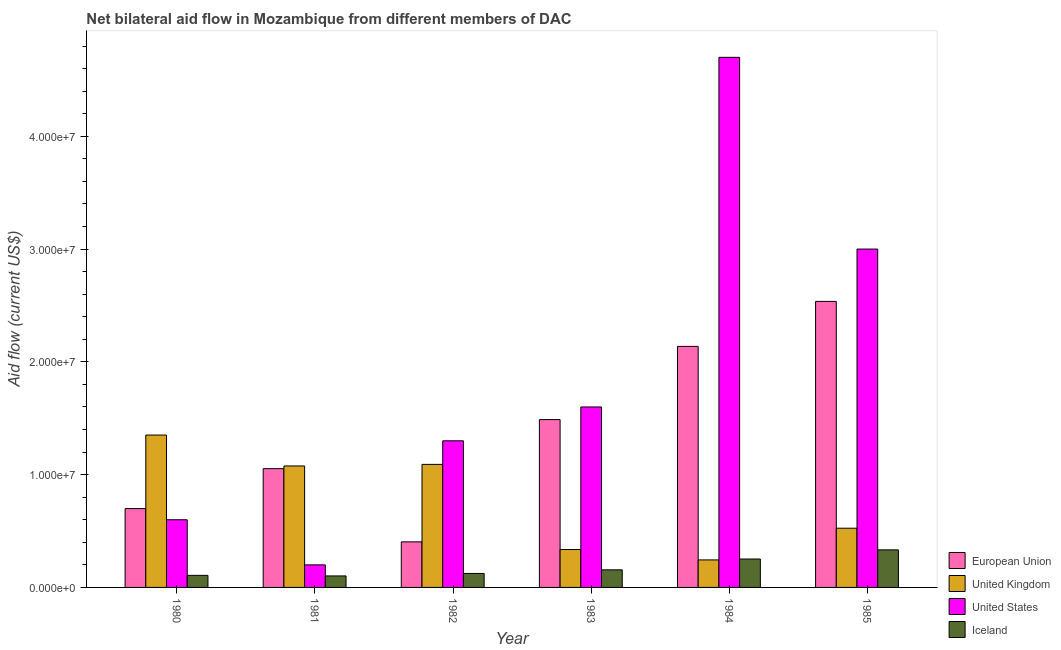How many groups of bars are there?
Make the answer very short. 6. Are the number of bars per tick equal to the number of legend labels?
Your answer should be compact. Yes. Are the number of bars on each tick of the X-axis equal?
Provide a short and direct response. Yes. How many bars are there on the 3rd tick from the right?
Keep it short and to the point. 4. What is the label of the 1st group of bars from the left?
Provide a short and direct response. 1980. What is the amount of aid given by eu in 1980?
Provide a short and direct response. 6.99e+06. Across all years, what is the maximum amount of aid given by iceland?
Your answer should be very brief. 3.33e+06. Across all years, what is the minimum amount of aid given by iceland?
Make the answer very short. 1.02e+06. In which year was the amount of aid given by iceland minimum?
Your answer should be compact. 1981. What is the total amount of aid given by us in the graph?
Keep it short and to the point. 1.14e+08. What is the difference between the amount of aid given by uk in 1981 and that in 1983?
Offer a very short reply. 7.41e+06. What is the difference between the amount of aid given by iceland in 1983 and the amount of aid given by uk in 1984?
Ensure brevity in your answer.  -9.60e+05. What is the average amount of aid given by uk per year?
Give a very brief answer. 7.71e+06. In the year 1981, what is the difference between the amount of aid given by iceland and amount of aid given by us?
Provide a short and direct response. 0. What is the ratio of the amount of aid given by eu in 1980 to that in 1982?
Make the answer very short. 1.73. Is the difference between the amount of aid given by us in 1981 and 1982 greater than the difference between the amount of aid given by iceland in 1981 and 1982?
Ensure brevity in your answer.  No. What is the difference between the highest and the second highest amount of aid given by eu?
Provide a short and direct response. 3.99e+06. What is the difference between the highest and the lowest amount of aid given by iceland?
Your response must be concise. 2.31e+06. In how many years, is the amount of aid given by iceland greater than the average amount of aid given by iceland taken over all years?
Make the answer very short. 2. Is it the case that in every year, the sum of the amount of aid given by eu and amount of aid given by iceland is greater than the sum of amount of aid given by uk and amount of aid given by us?
Offer a terse response. No. What does the 1st bar from the right in 1983 represents?
Ensure brevity in your answer.  Iceland. Is it the case that in every year, the sum of the amount of aid given by eu and amount of aid given by uk is greater than the amount of aid given by us?
Your answer should be very brief. No. Are all the bars in the graph horizontal?
Offer a terse response. No. How many years are there in the graph?
Your answer should be compact. 6. What is the difference between two consecutive major ticks on the Y-axis?
Ensure brevity in your answer.  1.00e+07. What is the title of the graph?
Your answer should be very brief. Net bilateral aid flow in Mozambique from different members of DAC. Does "Secondary general education" appear as one of the legend labels in the graph?
Your response must be concise. No. What is the label or title of the X-axis?
Offer a very short reply. Year. What is the Aid flow (current US$) in European Union in 1980?
Offer a terse response. 6.99e+06. What is the Aid flow (current US$) in United Kingdom in 1980?
Ensure brevity in your answer.  1.35e+07. What is the Aid flow (current US$) of United States in 1980?
Keep it short and to the point. 6.00e+06. What is the Aid flow (current US$) of Iceland in 1980?
Provide a short and direct response. 1.07e+06. What is the Aid flow (current US$) in European Union in 1981?
Provide a succinct answer. 1.05e+07. What is the Aid flow (current US$) of United Kingdom in 1981?
Provide a succinct answer. 1.08e+07. What is the Aid flow (current US$) in Iceland in 1981?
Your answer should be very brief. 1.02e+06. What is the Aid flow (current US$) of European Union in 1982?
Offer a terse response. 4.04e+06. What is the Aid flow (current US$) of United Kingdom in 1982?
Your answer should be very brief. 1.09e+07. What is the Aid flow (current US$) in United States in 1982?
Provide a short and direct response. 1.30e+07. What is the Aid flow (current US$) of Iceland in 1982?
Keep it short and to the point. 1.24e+06. What is the Aid flow (current US$) in European Union in 1983?
Your answer should be very brief. 1.49e+07. What is the Aid flow (current US$) in United Kingdom in 1983?
Offer a terse response. 3.36e+06. What is the Aid flow (current US$) of United States in 1983?
Your answer should be compact. 1.60e+07. What is the Aid flow (current US$) in Iceland in 1983?
Your answer should be very brief. 1.56e+06. What is the Aid flow (current US$) of European Union in 1984?
Your response must be concise. 2.14e+07. What is the Aid flow (current US$) of United Kingdom in 1984?
Offer a terse response. 2.44e+06. What is the Aid flow (current US$) of United States in 1984?
Provide a short and direct response. 4.70e+07. What is the Aid flow (current US$) of Iceland in 1984?
Provide a short and direct response. 2.52e+06. What is the Aid flow (current US$) in European Union in 1985?
Your answer should be very brief. 2.54e+07. What is the Aid flow (current US$) in United Kingdom in 1985?
Ensure brevity in your answer.  5.25e+06. What is the Aid flow (current US$) in United States in 1985?
Offer a very short reply. 3.00e+07. What is the Aid flow (current US$) in Iceland in 1985?
Your answer should be compact. 3.33e+06. Across all years, what is the maximum Aid flow (current US$) in European Union?
Keep it short and to the point. 2.54e+07. Across all years, what is the maximum Aid flow (current US$) of United Kingdom?
Provide a short and direct response. 1.35e+07. Across all years, what is the maximum Aid flow (current US$) of United States?
Give a very brief answer. 4.70e+07. Across all years, what is the maximum Aid flow (current US$) in Iceland?
Offer a very short reply. 3.33e+06. Across all years, what is the minimum Aid flow (current US$) of European Union?
Your response must be concise. 4.04e+06. Across all years, what is the minimum Aid flow (current US$) in United Kingdom?
Give a very brief answer. 2.44e+06. Across all years, what is the minimum Aid flow (current US$) of Iceland?
Keep it short and to the point. 1.02e+06. What is the total Aid flow (current US$) in European Union in the graph?
Give a very brief answer. 8.32e+07. What is the total Aid flow (current US$) of United Kingdom in the graph?
Provide a succinct answer. 4.62e+07. What is the total Aid flow (current US$) in United States in the graph?
Keep it short and to the point. 1.14e+08. What is the total Aid flow (current US$) in Iceland in the graph?
Provide a short and direct response. 1.07e+07. What is the difference between the Aid flow (current US$) in European Union in 1980 and that in 1981?
Provide a succinct answer. -3.54e+06. What is the difference between the Aid flow (current US$) in United Kingdom in 1980 and that in 1981?
Your answer should be very brief. 2.74e+06. What is the difference between the Aid flow (current US$) of Iceland in 1980 and that in 1981?
Make the answer very short. 5.00e+04. What is the difference between the Aid flow (current US$) of European Union in 1980 and that in 1982?
Provide a succinct answer. 2.95e+06. What is the difference between the Aid flow (current US$) in United Kingdom in 1980 and that in 1982?
Your response must be concise. 2.60e+06. What is the difference between the Aid flow (current US$) in United States in 1980 and that in 1982?
Keep it short and to the point. -7.00e+06. What is the difference between the Aid flow (current US$) of European Union in 1980 and that in 1983?
Provide a short and direct response. -7.89e+06. What is the difference between the Aid flow (current US$) of United Kingdom in 1980 and that in 1983?
Provide a succinct answer. 1.02e+07. What is the difference between the Aid flow (current US$) of United States in 1980 and that in 1983?
Your answer should be compact. -1.00e+07. What is the difference between the Aid flow (current US$) of Iceland in 1980 and that in 1983?
Provide a succinct answer. -4.90e+05. What is the difference between the Aid flow (current US$) in European Union in 1980 and that in 1984?
Provide a short and direct response. -1.44e+07. What is the difference between the Aid flow (current US$) of United Kingdom in 1980 and that in 1984?
Your answer should be compact. 1.11e+07. What is the difference between the Aid flow (current US$) of United States in 1980 and that in 1984?
Offer a terse response. -4.10e+07. What is the difference between the Aid flow (current US$) in Iceland in 1980 and that in 1984?
Ensure brevity in your answer.  -1.45e+06. What is the difference between the Aid flow (current US$) of European Union in 1980 and that in 1985?
Your answer should be compact. -1.84e+07. What is the difference between the Aid flow (current US$) of United Kingdom in 1980 and that in 1985?
Give a very brief answer. 8.26e+06. What is the difference between the Aid flow (current US$) of United States in 1980 and that in 1985?
Make the answer very short. -2.40e+07. What is the difference between the Aid flow (current US$) of Iceland in 1980 and that in 1985?
Offer a very short reply. -2.26e+06. What is the difference between the Aid flow (current US$) in European Union in 1981 and that in 1982?
Keep it short and to the point. 6.49e+06. What is the difference between the Aid flow (current US$) in United States in 1981 and that in 1982?
Offer a very short reply. -1.10e+07. What is the difference between the Aid flow (current US$) of Iceland in 1981 and that in 1982?
Keep it short and to the point. -2.20e+05. What is the difference between the Aid flow (current US$) in European Union in 1981 and that in 1983?
Offer a terse response. -4.35e+06. What is the difference between the Aid flow (current US$) in United Kingdom in 1981 and that in 1983?
Give a very brief answer. 7.41e+06. What is the difference between the Aid flow (current US$) of United States in 1981 and that in 1983?
Your answer should be compact. -1.40e+07. What is the difference between the Aid flow (current US$) in Iceland in 1981 and that in 1983?
Provide a succinct answer. -5.40e+05. What is the difference between the Aid flow (current US$) of European Union in 1981 and that in 1984?
Make the answer very short. -1.08e+07. What is the difference between the Aid flow (current US$) of United Kingdom in 1981 and that in 1984?
Your answer should be very brief. 8.33e+06. What is the difference between the Aid flow (current US$) of United States in 1981 and that in 1984?
Make the answer very short. -4.50e+07. What is the difference between the Aid flow (current US$) in Iceland in 1981 and that in 1984?
Ensure brevity in your answer.  -1.50e+06. What is the difference between the Aid flow (current US$) of European Union in 1981 and that in 1985?
Keep it short and to the point. -1.48e+07. What is the difference between the Aid flow (current US$) in United Kingdom in 1981 and that in 1985?
Keep it short and to the point. 5.52e+06. What is the difference between the Aid flow (current US$) of United States in 1981 and that in 1985?
Your answer should be compact. -2.80e+07. What is the difference between the Aid flow (current US$) of Iceland in 1981 and that in 1985?
Ensure brevity in your answer.  -2.31e+06. What is the difference between the Aid flow (current US$) of European Union in 1982 and that in 1983?
Offer a very short reply. -1.08e+07. What is the difference between the Aid flow (current US$) of United Kingdom in 1982 and that in 1983?
Make the answer very short. 7.55e+06. What is the difference between the Aid flow (current US$) of United States in 1982 and that in 1983?
Offer a terse response. -3.00e+06. What is the difference between the Aid flow (current US$) in Iceland in 1982 and that in 1983?
Offer a very short reply. -3.20e+05. What is the difference between the Aid flow (current US$) of European Union in 1982 and that in 1984?
Make the answer very short. -1.73e+07. What is the difference between the Aid flow (current US$) of United Kingdom in 1982 and that in 1984?
Your answer should be very brief. 8.47e+06. What is the difference between the Aid flow (current US$) in United States in 1982 and that in 1984?
Keep it short and to the point. -3.40e+07. What is the difference between the Aid flow (current US$) in Iceland in 1982 and that in 1984?
Provide a short and direct response. -1.28e+06. What is the difference between the Aid flow (current US$) of European Union in 1982 and that in 1985?
Keep it short and to the point. -2.13e+07. What is the difference between the Aid flow (current US$) of United Kingdom in 1982 and that in 1985?
Provide a short and direct response. 5.66e+06. What is the difference between the Aid flow (current US$) of United States in 1982 and that in 1985?
Make the answer very short. -1.70e+07. What is the difference between the Aid flow (current US$) of Iceland in 1982 and that in 1985?
Keep it short and to the point. -2.09e+06. What is the difference between the Aid flow (current US$) of European Union in 1983 and that in 1984?
Offer a very short reply. -6.49e+06. What is the difference between the Aid flow (current US$) in United Kingdom in 1983 and that in 1984?
Offer a very short reply. 9.20e+05. What is the difference between the Aid flow (current US$) of United States in 1983 and that in 1984?
Offer a terse response. -3.10e+07. What is the difference between the Aid flow (current US$) of Iceland in 1983 and that in 1984?
Your response must be concise. -9.60e+05. What is the difference between the Aid flow (current US$) of European Union in 1983 and that in 1985?
Ensure brevity in your answer.  -1.05e+07. What is the difference between the Aid flow (current US$) of United Kingdom in 1983 and that in 1985?
Make the answer very short. -1.89e+06. What is the difference between the Aid flow (current US$) in United States in 1983 and that in 1985?
Keep it short and to the point. -1.40e+07. What is the difference between the Aid flow (current US$) in Iceland in 1983 and that in 1985?
Ensure brevity in your answer.  -1.77e+06. What is the difference between the Aid flow (current US$) in European Union in 1984 and that in 1985?
Your answer should be compact. -3.99e+06. What is the difference between the Aid flow (current US$) of United Kingdom in 1984 and that in 1985?
Offer a very short reply. -2.81e+06. What is the difference between the Aid flow (current US$) in United States in 1984 and that in 1985?
Offer a terse response. 1.70e+07. What is the difference between the Aid flow (current US$) in Iceland in 1984 and that in 1985?
Provide a succinct answer. -8.10e+05. What is the difference between the Aid flow (current US$) in European Union in 1980 and the Aid flow (current US$) in United Kingdom in 1981?
Your answer should be very brief. -3.78e+06. What is the difference between the Aid flow (current US$) of European Union in 1980 and the Aid flow (current US$) of United States in 1981?
Your response must be concise. 4.99e+06. What is the difference between the Aid flow (current US$) in European Union in 1980 and the Aid flow (current US$) in Iceland in 1981?
Keep it short and to the point. 5.97e+06. What is the difference between the Aid flow (current US$) in United Kingdom in 1980 and the Aid flow (current US$) in United States in 1981?
Give a very brief answer. 1.15e+07. What is the difference between the Aid flow (current US$) in United Kingdom in 1980 and the Aid flow (current US$) in Iceland in 1981?
Ensure brevity in your answer.  1.25e+07. What is the difference between the Aid flow (current US$) of United States in 1980 and the Aid flow (current US$) of Iceland in 1981?
Keep it short and to the point. 4.98e+06. What is the difference between the Aid flow (current US$) in European Union in 1980 and the Aid flow (current US$) in United Kingdom in 1982?
Offer a terse response. -3.92e+06. What is the difference between the Aid flow (current US$) of European Union in 1980 and the Aid flow (current US$) of United States in 1982?
Offer a very short reply. -6.01e+06. What is the difference between the Aid flow (current US$) of European Union in 1980 and the Aid flow (current US$) of Iceland in 1982?
Your response must be concise. 5.75e+06. What is the difference between the Aid flow (current US$) of United Kingdom in 1980 and the Aid flow (current US$) of United States in 1982?
Provide a succinct answer. 5.10e+05. What is the difference between the Aid flow (current US$) in United Kingdom in 1980 and the Aid flow (current US$) in Iceland in 1982?
Offer a very short reply. 1.23e+07. What is the difference between the Aid flow (current US$) of United States in 1980 and the Aid flow (current US$) of Iceland in 1982?
Offer a terse response. 4.76e+06. What is the difference between the Aid flow (current US$) in European Union in 1980 and the Aid flow (current US$) in United Kingdom in 1983?
Make the answer very short. 3.63e+06. What is the difference between the Aid flow (current US$) of European Union in 1980 and the Aid flow (current US$) of United States in 1983?
Keep it short and to the point. -9.01e+06. What is the difference between the Aid flow (current US$) of European Union in 1980 and the Aid flow (current US$) of Iceland in 1983?
Ensure brevity in your answer.  5.43e+06. What is the difference between the Aid flow (current US$) in United Kingdom in 1980 and the Aid flow (current US$) in United States in 1983?
Your answer should be very brief. -2.49e+06. What is the difference between the Aid flow (current US$) in United Kingdom in 1980 and the Aid flow (current US$) in Iceland in 1983?
Offer a very short reply. 1.20e+07. What is the difference between the Aid flow (current US$) of United States in 1980 and the Aid flow (current US$) of Iceland in 1983?
Provide a short and direct response. 4.44e+06. What is the difference between the Aid flow (current US$) of European Union in 1980 and the Aid flow (current US$) of United Kingdom in 1984?
Provide a short and direct response. 4.55e+06. What is the difference between the Aid flow (current US$) in European Union in 1980 and the Aid flow (current US$) in United States in 1984?
Keep it short and to the point. -4.00e+07. What is the difference between the Aid flow (current US$) in European Union in 1980 and the Aid flow (current US$) in Iceland in 1984?
Your answer should be compact. 4.47e+06. What is the difference between the Aid flow (current US$) in United Kingdom in 1980 and the Aid flow (current US$) in United States in 1984?
Provide a short and direct response. -3.35e+07. What is the difference between the Aid flow (current US$) in United Kingdom in 1980 and the Aid flow (current US$) in Iceland in 1984?
Offer a terse response. 1.10e+07. What is the difference between the Aid flow (current US$) in United States in 1980 and the Aid flow (current US$) in Iceland in 1984?
Ensure brevity in your answer.  3.48e+06. What is the difference between the Aid flow (current US$) of European Union in 1980 and the Aid flow (current US$) of United Kingdom in 1985?
Make the answer very short. 1.74e+06. What is the difference between the Aid flow (current US$) of European Union in 1980 and the Aid flow (current US$) of United States in 1985?
Ensure brevity in your answer.  -2.30e+07. What is the difference between the Aid flow (current US$) in European Union in 1980 and the Aid flow (current US$) in Iceland in 1985?
Make the answer very short. 3.66e+06. What is the difference between the Aid flow (current US$) of United Kingdom in 1980 and the Aid flow (current US$) of United States in 1985?
Keep it short and to the point. -1.65e+07. What is the difference between the Aid flow (current US$) of United Kingdom in 1980 and the Aid flow (current US$) of Iceland in 1985?
Provide a succinct answer. 1.02e+07. What is the difference between the Aid flow (current US$) in United States in 1980 and the Aid flow (current US$) in Iceland in 1985?
Make the answer very short. 2.67e+06. What is the difference between the Aid flow (current US$) of European Union in 1981 and the Aid flow (current US$) of United Kingdom in 1982?
Keep it short and to the point. -3.80e+05. What is the difference between the Aid flow (current US$) in European Union in 1981 and the Aid flow (current US$) in United States in 1982?
Offer a very short reply. -2.47e+06. What is the difference between the Aid flow (current US$) in European Union in 1981 and the Aid flow (current US$) in Iceland in 1982?
Provide a succinct answer. 9.29e+06. What is the difference between the Aid flow (current US$) of United Kingdom in 1981 and the Aid flow (current US$) of United States in 1982?
Offer a terse response. -2.23e+06. What is the difference between the Aid flow (current US$) of United Kingdom in 1981 and the Aid flow (current US$) of Iceland in 1982?
Provide a short and direct response. 9.53e+06. What is the difference between the Aid flow (current US$) in United States in 1981 and the Aid flow (current US$) in Iceland in 1982?
Make the answer very short. 7.60e+05. What is the difference between the Aid flow (current US$) in European Union in 1981 and the Aid flow (current US$) in United Kingdom in 1983?
Ensure brevity in your answer.  7.17e+06. What is the difference between the Aid flow (current US$) in European Union in 1981 and the Aid flow (current US$) in United States in 1983?
Your response must be concise. -5.47e+06. What is the difference between the Aid flow (current US$) of European Union in 1981 and the Aid flow (current US$) of Iceland in 1983?
Provide a short and direct response. 8.97e+06. What is the difference between the Aid flow (current US$) in United Kingdom in 1981 and the Aid flow (current US$) in United States in 1983?
Make the answer very short. -5.23e+06. What is the difference between the Aid flow (current US$) of United Kingdom in 1981 and the Aid flow (current US$) of Iceland in 1983?
Provide a short and direct response. 9.21e+06. What is the difference between the Aid flow (current US$) of European Union in 1981 and the Aid flow (current US$) of United Kingdom in 1984?
Keep it short and to the point. 8.09e+06. What is the difference between the Aid flow (current US$) in European Union in 1981 and the Aid flow (current US$) in United States in 1984?
Keep it short and to the point. -3.65e+07. What is the difference between the Aid flow (current US$) of European Union in 1981 and the Aid flow (current US$) of Iceland in 1984?
Provide a short and direct response. 8.01e+06. What is the difference between the Aid flow (current US$) in United Kingdom in 1981 and the Aid flow (current US$) in United States in 1984?
Your answer should be compact. -3.62e+07. What is the difference between the Aid flow (current US$) in United Kingdom in 1981 and the Aid flow (current US$) in Iceland in 1984?
Provide a short and direct response. 8.25e+06. What is the difference between the Aid flow (current US$) of United States in 1981 and the Aid flow (current US$) of Iceland in 1984?
Provide a succinct answer. -5.20e+05. What is the difference between the Aid flow (current US$) in European Union in 1981 and the Aid flow (current US$) in United Kingdom in 1985?
Your answer should be very brief. 5.28e+06. What is the difference between the Aid flow (current US$) of European Union in 1981 and the Aid flow (current US$) of United States in 1985?
Make the answer very short. -1.95e+07. What is the difference between the Aid flow (current US$) of European Union in 1981 and the Aid flow (current US$) of Iceland in 1985?
Make the answer very short. 7.20e+06. What is the difference between the Aid flow (current US$) of United Kingdom in 1981 and the Aid flow (current US$) of United States in 1985?
Keep it short and to the point. -1.92e+07. What is the difference between the Aid flow (current US$) in United Kingdom in 1981 and the Aid flow (current US$) in Iceland in 1985?
Give a very brief answer. 7.44e+06. What is the difference between the Aid flow (current US$) in United States in 1981 and the Aid flow (current US$) in Iceland in 1985?
Make the answer very short. -1.33e+06. What is the difference between the Aid flow (current US$) in European Union in 1982 and the Aid flow (current US$) in United Kingdom in 1983?
Your answer should be compact. 6.80e+05. What is the difference between the Aid flow (current US$) in European Union in 1982 and the Aid flow (current US$) in United States in 1983?
Your answer should be compact. -1.20e+07. What is the difference between the Aid flow (current US$) of European Union in 1982 and the Aid flow (current US$) of Iceland in 1983?
Your response must be concise. 2.48e+06. What is the difference between the Aid flow (current US$) of United Kingdom in 1982 and the Aid flow (current US$) of United States in 1983?
Give a very brief answer. -5.09e+06. What is the difference between the Aid flow (current US$) of United Kingdom in 1982 and the Aid flow (current US$) of Iceland in 1983?
Your answer should be compact. 9.35e+06. What is the difference between the Aid flow (current US$) in United States in 1982 and the Aid flow (current US$) in Iceland in 1983?
Your answer should be very brief. 1.14e+07. What is the difference between the Aid flow (current US$) in European Union in 1982 and the Aid flow (current US$) in United Kingdom in 1984?
Give a very brief answer. 1.60e+06. What is the difference between the Aid flow (current US$) of European Union in 1982 and the Aid flow (current US$) of United States in 1984?
Keep it short and to the point. -4.30e+07. What is the difference between the Aid flow (current US$) of European Union in 1982 and the Aid flow (current US$) of Iceland in 1984?
Provide a short and direct response. 1.52e+06. What is the difference between the Aid flow (current US$) in United Kingdom in 1982 and the Aid flow (current US$) in United States in 1984?
Offer a terse response. -3.61e+07. What is the difference between the Aid flow (current US$) of United Kingdom in 1982 and the Aid flow (current US$) of Iceland in 1984?
Keep it short and to the point. 8.39e+06. What is the difference between the Aid flow (current US$) of United States in 1982 and the Aid flow (current US$) of Iceland in 1984?
Your answer should be very brief. 1.05e+07. What is the difference between the Aid flow (current US$) of European Union in 1982 and the Aid flow (current US$) of United Kingdom in 1985?
Your answer should be compact. -1.21e+06. What is the difference between the Aid flow (current US$) of European Union in 1982 and the Aid flow (current US$) of United States in 1985?
Provide a succinct answer. -2.60e+07. What is the difference between the Aid flow (current US$) in European Union in 1982 and the Aid flow (current US$) in Iceland in 1985?
Keep it short and to the point. 7.10e+05. What is the difference between the Aid flow (current US$) of United Kingdom in 1982 and the Aid flow (current US$) of United States in 1985?
Offer a terse response. -1.91e+07. What is the difference between the Aid flow (current US$) in United Kingdom in 1982 and the Aid flow (current US$) in Iceland in 1985?
Your response must be concise. 7.58e+06. What is the difference between the Aid flow (current US$) in United States in 1982 and the Aid flow (current US$) in Iceland in 1985?
Make the answer very short. 9.67e+06. What is the difference between the Aid flow (current US$) of European Union in 1983 and the Aid flow (current US$) of United Kingdom in 1984?
Make the answer very short. 1.24e+07. What is the difference between the Aid flow (current US$) in European Union in 1983 and the Aid flow (current US$) in United States in 1984?
Give a very brief answer. -3.21e+07. What is the difference between the Aid flow (current US$) in European Union in 1983 and the Aid flow (current US$) in Iceland in 1984?
Your response must be concise. 1.24e+07. What is the difference between the Aid flow (current US$) of United Kingdom in 1983 and the Aid flow (current US$) of United States in 1984?
Ensure brevity in your answer.  -4.36e+07. What is the difference between the Aid flow (current US$) of United Kingdom in 1983 and the Aid flow (current US$) of Iceland in 1984?
Ensure brevity in your answer.  8.40e+05. What is the difference between the Aid flow (current US$) of United States in 1983 and the Aid flow (current US$) of Iceland in 1984?
Offer a very short reply. 1.35e+07. What is the difference between the Aid flow (current US$) in European Union in 1983 and the Aid flow (current US$) in United Kingdom in 1985?
Make the answer very short. 9.63e+06. What is the difference between the Aid flow (current US$) in European Union in 1983 and the Aid flow (current US$) in United States in 1985?
Your response must be concise. -1.51e+07. What is the difference between the Aid flow (current US$) of European Union in 1983 and the Aid flow (current US$) of Iceland in 1985?
Your answer should be very brief. 1.16e+07. What is the difference between the Aid flow (current US$) in United Kingdom in 1983 and the Aid flow (current US$) in United States in 1985?
Make the answer very short. -2.66e+07. What is the difference between the Aid flow (current US$) in United Kingdom in 1983 and the Aid flow (current US$) in Iceland in 1985?
Offer a very short reply. 3.00e+04. What is the difference between the Aid flow (current US$) of United States in 1983 and the Aid flow (current US$) of Iceland in 1985?
Offer a terse response. 1.27e+07. What is the difference between the Aid flow (current US$) of European Union in 1984 and the Aid flow (current US$) of United Kingdom in 1985?
Your answer should be compact. 1.61e+07. What is the difference between the Aid flow (current US$) in European Union in 1984 and the Aid flow (current US$) in United States in 1985?
Provide a short and direct response. -8.63e+06. What is the difference between the Aid flow (current US$) in European Union in 1984 and the Aid flow (current US$) in Iceland in 1985?
Make the answer very short. 1.80e+07. What is the difference between the Aid flow (current US$) in United Kingdom in 1984 and the Aid flow (current US$) in United States in 1985?
Offer a very short reply. -2.76e+07. What is the difference between the Aid flow (current US$) of United Kingdom in 1984 and the Aid flow (current US$) of Iceland in 1985?
Your answer should be compact. -8.90e+05. What is the difference between the Aid flow (current US$) in United States in 1984 and the Aid flow (current US$) in Iceland in 1985?
Make the answer very short. 4.37e+07. What is the average Aid flow (current US$) of European Union per year?
Keep it short and to the point. 1.39e+07. What is the average Aid flow (current US$) in United Kingdom per year?
Make the answer very short. 7.71e+06. What is the average Aid flow (current US$) of United States per year?
Give a very brief answer. 1.90e+07. What is the average Aid flow (current US$) in Iceland per year?
Your answer should be compact. 1.79e+06. In the year 1980, what is the difference between the Aid flow (current US$) of European Union and Aid flow (current US$) of United Kingdom?
Your answer should be very brief. -6.52e+06. In the year 1980, what is the difference between the Aid flow (current US$) in European Union and Aid flow (current US$) in United States?
Your answer should be compact. 9.90e+05. In the year 1980, what is the difference between the Aid flow (current US$) of European Union and Aid flow (current US$) of Iceland?
Keep it short and to the point. 5.92e+06. In the year 1980, what is the difference between the Aid flow (current US$) of United Kingdom and Aid flow (current US$) of United States?
Offer a very short reply. 7.51e+06. In the year 1980, what is the difference between the Aid flow (current US$) of United Kingdom and Aid flow (current US$) of Iceland?
Ensure brevity in your answer.  1.24e+07. In the year 1980, what is the difference between the Aid flow (current US$) of United States and Aid flow (current US$) of Iceland?
Make the answer very short. 4.93e+06. In the year 1981, what is the difference between the Aid flow (current US$) of European Union and Aid flow (current US$) of United Kingdom?
Offer a very short reply. -2.40e+05. In the year 1981, what is the difference between the Aid flow (current US$) of European Union and Aid flow (current US$) of United States?
Keep it short and to the point. 8.53e+06. In the year 1981, what is the difference between the Aid flow (current US$) of European Union and Aid flow (current US$) of Iceland?
Your answer should be compact. 9.51e+06. In the year 1981, what is the difference between the Aid flow (current US$) of United Kingdom and Aid flow (current US$) of United States?
Make the answer very short. 8.77e+06. In the year 1981, what is the difference between the Aid flow (current US$) of United Kingdom and Aid flow (current US$) of Iceland?
Offer a terse response. 9.75e+06. In the year 1981, what is the difference between the Aid flow (current US$) in United States and Aid flow (current US$) in Iceland?
Make the answer very short. 9.80e+05. In the year 1982, what is the difference between the Aid flow (current US$) in European Union and Aid flow (current US$) in United Kingdom?
Provide a succinct answer. -6.87e+06. In the year 1982, what is the difference between the Aid flow (current US$) of European Union and Aid flow (current US$) of United States?
Provide a short and direct response. -8.96e+06. In the year 1982, what is the difference between the Aid flow (current US$) of European Union and Aid flow (current US$) of Iceland?
Keep it short and to the point. 2.80e+06. In the year 1982, what is the difference between the Aid flow (current US$) of United Kingdom and Aid flow (current US$) of United States?
Your answer should be very brief. -2.09e+06. In the year 1982, what is the difference between the Aid flow (current US$) of United Kingdom and Aid flow (current US$) of Iceland?
Give a very brief answer. 9.67e+06. In the year 1982, what is the difference between the Aid flow (current US$) of United States and Aid flow (current US$) of Iceland?
Your response must be concise. 1.18e+07. In the year 1983, what is the difference between the Aid flow (current US$) of European Union and Aid flow (current US$) of United Kingdom?
Offer a terse response. 1.15e+07. In the year 1983, what is the difference between the Aid flow (current US$) in European Union and Aid flow (current US$) in United States?
Keep it short and to the point. -1.12e+06. In the year 1983, what is the difference between the Aid flow (current US$) in European Union and Aid flow (current US$) in Iceland?
Keep it short and to the point. 1.33e+07. In the year 1983, what is the difference between the Aid flow (current US$) of United Kingdom and Aid flow (current US$) of United States?
Offer a terse response. -1.26e+07. In the year 1983, what is the difference between the Aid flow (current US$) of United Kingdom and Aid flow (current US$) of Iceland?
Your response must be concise. 1.80e+06. In the year 1983, what is the difference between the Aid flow (current US$) in United States and Aid flow (current US$) in Iceland?
Ensure brevity in your answer.  1.44e+07. In the year 1984, what is the difference between the Aid flow (current US$) of European Union and Aid flow (current US$) of United Kingdom?
Make the answer very short. 1.89e+07. In the year 1984, what is the difference between the Aid flow (current US$) in European Union and Aid flow (current US$) in United States?
Provide a short and direct response. -2.56e+07. In the year 1984, what is the difference between the Aid flow (current US$) in European Union and Aid flow (current US$) in Iceland?
Keep it short and to the point. 1.88e+07. In the year 1984, what is the difference between the Aid flow (current US$) in United Kingdom and Aid flow (current US$) in United States?
Your answer should be compact. -4.46e+07. In the year 1984, what is the difference between the Aid flow (current US$) of United States and Aid flow (current US$) of Iceland?
Make the answer very short. 4.45e+07. In the year 1985, what is the difference between the Aid flow (current US$) of European Union and Aid flow (current US$) of United Kingdom?
Your answer should be compact. 2.01e+07. In the year 1985, what is the difference between the Aid flow (current US$) of European Union and Aid flow (current US$) of United States?
Give a very brief answer. -4.64e+06. In the year 1985, what is the difference between the Aid flow (current US$) in European Union and Aid flow (current US$) in Iceland?
Offer a very short reply. 2.20e+07. In the year 1985, what is the difference between the Aid flow (current US$) of United Kingdom and Aid flow (current US$) of United States?
Provide a short and direct response. -2.48e+07. In the year 1985, what is the difference between the Aid flow (current US$) of United Kingdom and Aid flow (current US$) of Iceland?
Your answer should be compact. 1.92e+06. In the year 1985, what is the difference between the Aid flow (current US$) of United States and Aid flow (current US$) of Iceland?
Keep it short and to the point. 2.67e+07. What is the ratio of the Aid flow (current US$) in European Union in 1980 to that in 1981?
Provide a short and direct response. 0.66. What is the ratio of the Aid flow (current US$) of United Kingdom in 1980 to that in 1981?
Provide a succinct answer. 1.25. What is the ratio of the Aid flow (current US$) of Iceland in 1980 to that in 1981?
Keep it short and to the point. 1.05. What is the ratio of the Aid flow (current US$) in European Union in 1980 to that in 1982?
Make the answer very short. 1.73. What is the ratio of the Aid flow (current US$) of United Kingdom in 1980 to that in 1982?
Your answer should be very brief. 1.24. What is the ratio of the Aid flow (current US$) of United States in 1980 to that in 1982?
Your response must be concise. 0.46. What is the ratio of the Aid flow (current US$) in Iceland in 1980 to that in 1982?
Keep it short and to the point. 0.86. What is the ratio of the Aid flow (current US$) of European Union in 1980 to that in 1983?
Keep it short and to the point. 0.47. What is the ratio of the Aid flow (current US$) in United Kingdom in 1980 to that in 1983?
Give a very brief answer. 4.02. What is the ratio of the Aid flow (current US$) of United States in 1980 to that in 1983?
Provide a short and direct response. 0.38. What is the ratio of the Aid flow (current US$) in Iceland in 1980 to that in 1983?
Make the answer very short. 0.69. What is the ratio of the Aid flow (current US$) in European Union in 1980 to that in 1984?
Ensure brevity in your answer.  0.33. What is the ratio of the Aid flow (current US$) in United Kingdom in 1980 to that in 1984?
Your answer should be compact. 5.54. What is the ratio of the Aid flow (current US$) in United States in 1980 to that in 1984?
Provide a succinct answer. 0.13. What is the ratio of the Aid flow (current US$) in Iceland in 1980 to that in 1984?
Keep it short and to the point. 0.42. What is the ratio of the Aid flow (current US$) in European Union in 1980 to that in 1985?
Make the answer very short. 0.28. What is the ratio of the Aid flow (current US$) in United Kingdom in 1980 to that in 1985?
Provide a succinct answer. 2.57. What is the ratio of the Aid flow (current US$) of Iceland in 1980 to that in 1985?
Give a very brief answer. 0.32. What is the ratio of the Aid flow (current US$) of European Union in 1981 to that in 1982?
Ensure brevity in your answer.  2.61. What is the ratio of the Aid flow (current US$) of United Kingdom in 1981 to that in 1982?
Give a very brief answer. 0.99. What is the ratio of the Aid flow (current US$) in United States in 1981 to that in 1982?
Ensure brevity in your answer.  0.15. What is the ratio of the Aid flow (current US$) in Iceland in 1981 to that in 1982?
Your answer should be compact. 0.82. What is the ratio of the Aid flow (current US$) of European Union in 1981 to that in 1983?
Your response must be concise. 0.71. What is the ratio of the Aid flow (current US$) of United Kingdom in 1981 to that in 1983?
Your answer should be compact. 3.21. What is the ratio of the Aid flow (current US$) in United States in 1981 to that in 1983?
Provide a succinct answer. 0.12. What is the ratio of the Aid flow (current US$) of Iceland in 1981 to that in 1983?
Your answer should be compact. 0.65. What is the ratio of the Aid flow (current US$) of European Union in 1981 to that in 1984?
Keep it short and to the point. 0.49. What is the ratio of the Aid flow (current US$) in United Kingdom in 1981 to that in 1984?
Your answer should be very brief. 4.41. What is the ratio of the Aid flow (current US$) in United States in 1981 to that in 1984?
Ensure brevity in your answer.  0.04. What is the ratio of the Aid flow (current US$) of Iceland in 1981 to that in 1984?
Your answer should be very brief. 0.4. What is the ratio of the Aid flow (current US$) in European Union in 1981 to that in 1985?
Make the answer very short. 0.42. What is the ratio of the Aid flow (current US$) in United Kingdom in 1981 to that in 1985?
Your response must be concise. 2.05. What is the ratio of the Aid flow (current US$) in United States in 1981 to that in 1985?
Offer a terse response. 0.07. What is the ratio of the Aid flow (current US$) in Iceland in 1981 to that in 1985?
Offer a terse response. 0.31. What is the ratio of the Aid flow (current US$) of European Union in 1982 to that in 1983?
Provide a short and direct response. 0.27. What is the ratio of the Aid flow (current US$) in United Kingdom in 1982 to that in 1983?
Make the answer very short. 3.25. What is the ratio of the Aid flow (current US$) of United States in 1982 to that in 1983?
Your response must be concise. 0.81. What is the ratio of the Aid flow (current US$) of Iceland in 1982 to that in 1983?
Make the answer very short. 0.79. What is the ratio of the Aid flow (current US$) of European Union in 1982 to that in 1984?
Your answer should be very brief. 0.19. What is the ratio of the Aid flow (current US$) in United Kingdom in 1982 to that in 1984?
Your response must be concise. 4.47. What is the ratio of the Aid flow (current US$) of United States in 1982 to that in 1984?
Your answer should be compact. 0.28. What is the ratio of the Aid flow (current US$) in Iceland in 1982 to that in 1984?
Your answer should be compact. 0.49. What is the ratio of the Aid flow (current US$) in European Union in 1982 to that in 1985?
Ensure brevity in your answer.  0.16. What is the ratio of the Aid flow (current US$) in United Kingdom in 1982 to that in 1985?
Your response must be concise. 2.08. What is the ratio of the Aid flow (current US$) in United States in 1982 to that in 1985?
Your response must be concise. 0.43. What is the ratio of the Aid flow (current US$) in Iceland in 1982 to that in 1985?
Your answer should be compact. 0.37. What is the ratio of the Aid flow (current US$) of European Union in 1983 to that in 1984?
Offer a terse response. 0.7. What is the ratio of the Aid flow (current US$) of United Kingdom in 1983 to that in 1984?
Offer a terse response. 1.38. What is the ratio of the Aid flow (current US$) of United States in 1983 to that in 1984?
Keep it short and to the point. 0.34. What is the ratio of the Aid flow (current US$) in Iceland in 1983 to that in 1984?
Offer a terse response. 0.62. What is the ratio of the Aid flow (current US$) of European Union in 1983 to that in 1985?
Provide a short and direct response. 0.59. What is the ratio of the Aid flow (current US$) in United Kingdom in 1983 to that in 1985?
Provide a succinct answer. 0.64. What is the ratio of the Aid flow (current US$) of United States in 1983 to that in 1985?
Make the answer very short. 0.53. What is the ratio of the Aid flow (current US$) in Iceland in 1983 to that in 1985?
Your response must be concise. 0.47. What is the ratio of the Aid flow (current US$) of European Union in 1984 to that in 1985?
Provide a short and direct response. 0.84. What is the ratio of the Aid flow (current US$) of United Kingdom in 1984 to that in 1985?
Your answer should be compact. 0.46. What is the ratio of the Aid flow (current US$) in United States in 1984 to that in 1985?
Offer a terse response. 1.57. What is the ratio of the Aid flow (current US$) in Iceland in 1984 to that in 1985?
Your answer should be compact. 0.76. What is the difference between the highest and the second highest Aid flow (current US$) of European Union?
Keep it short and to the point. 3.99e+06. What is the difference between the highest and the second highest Aid flow (current US$) of United Kingdom?
Ensure brevity in your answer.  2.60e+06. What is the difference between the highest and the second highest Aid flow (current US$) of United States?
Make the answer very short. 1.70e+07. What is the difference between the highest and the second highest Aid flow (current US$) of Iceland?
Provide a short and direct response. 8.10e+05. What is the difference between the highest and the lowest Aid flow (current US$) in European Union?
Your answer should be very brief. 2.13e+07. What is the difference between the highest and the lowest Aid flow (current US$) in United Kingdom?
Ensure brevity in your answer.  1.11e+07. What is the difference between the highest and the lowest Aid flow (current US$) of United States?
Provide a succinct answer. 4.50e+07. What is the difference between the highest and the lowest Aid flow (current US$) in Iceland?
Give a very brief answer. 2.31e+06. 